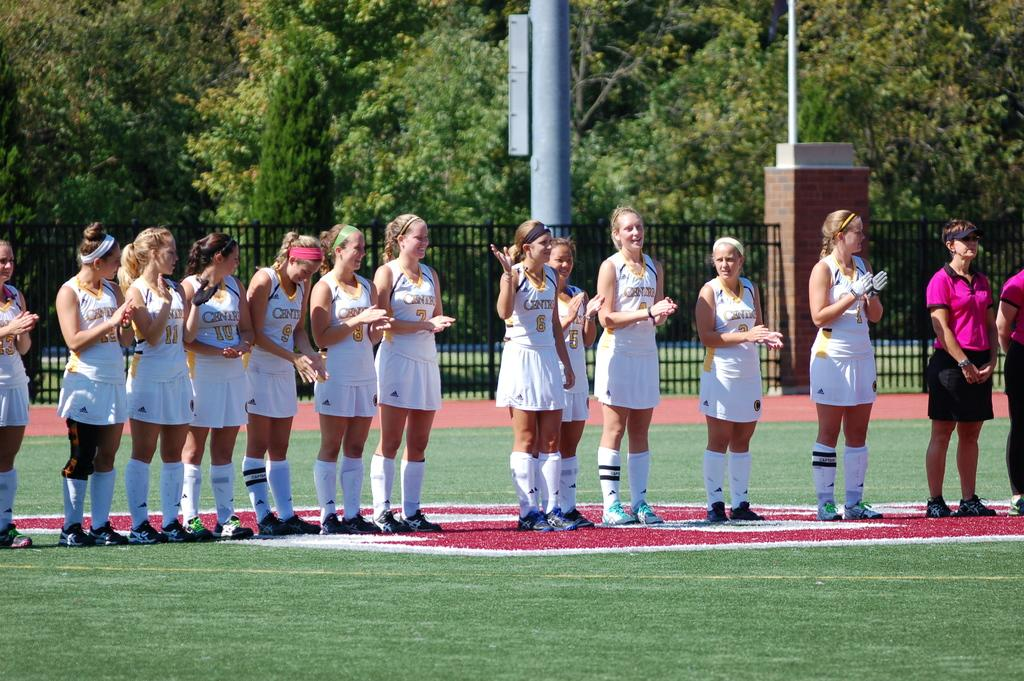What is the main subject of the image? The main subject of the image is a group of women. What are the women doing in the image? The women are standing in the image. What are the women wearing in the image? The women are wearing white dresses in the image. What can be seen in the background of the image? There are trees, a fence, and grass in the background of the image. What type of payment is being made by the women in the image? There is no indication of any payment being made in the image; the women are simply standing and wearing white dresses. 